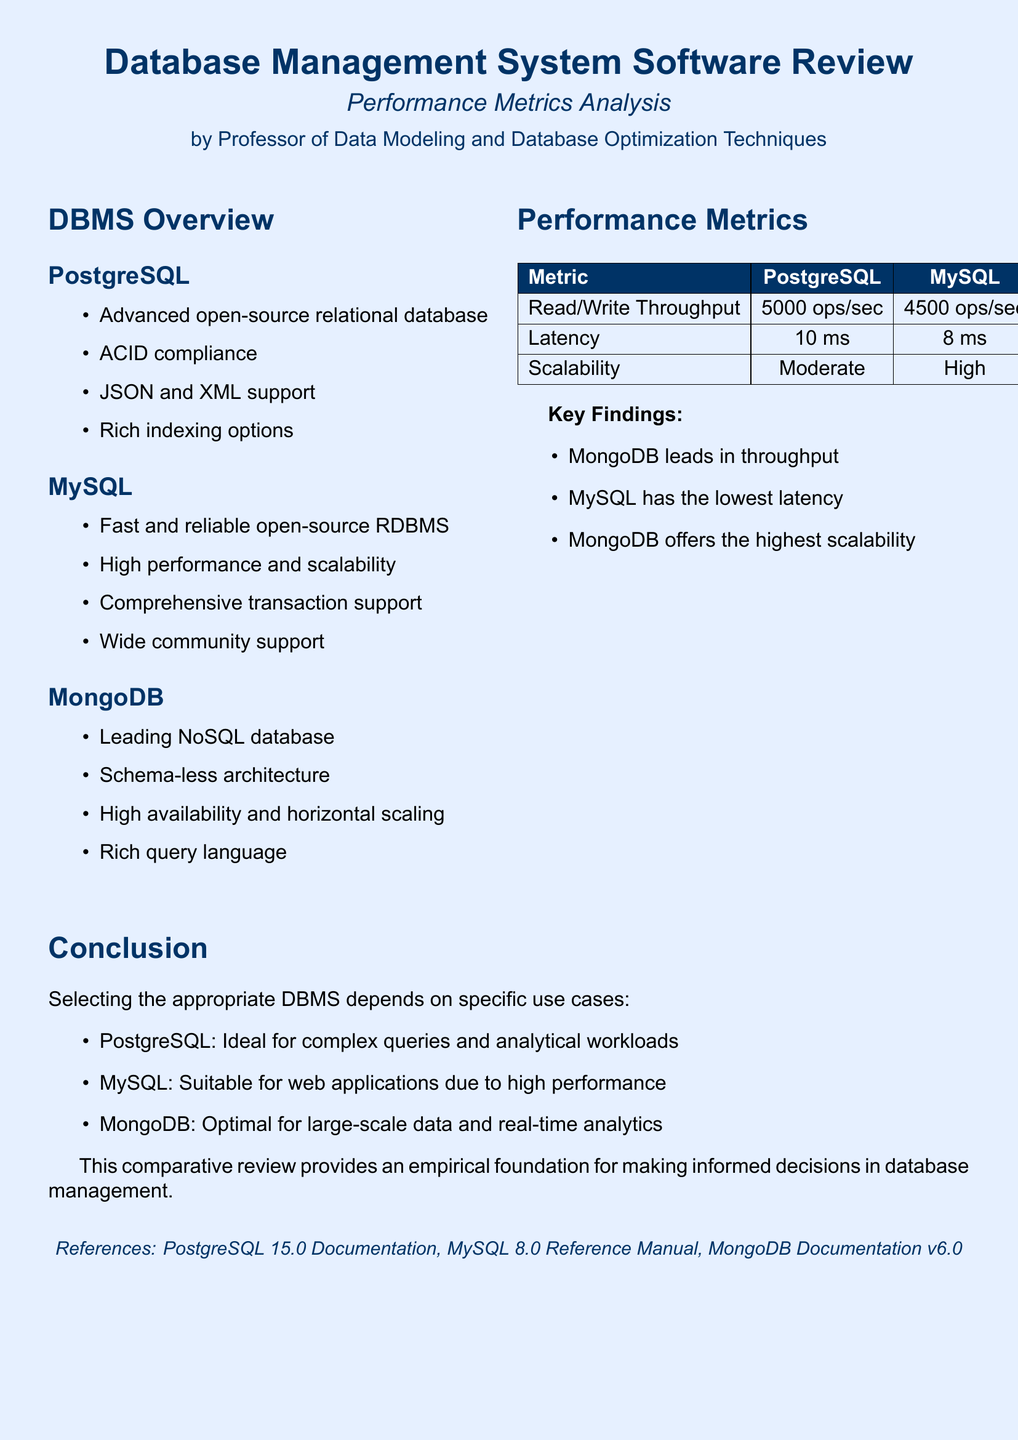What is the throughput for PostgreSQL? The throughput for PostgreSQL is listed under the Read/Write Throughput metric in the document.
Answer: 5000 ops/sec What is the latency figure for MySQL? The latency figure for MySQL can be found in the Performance Metrics table of the document.
Answer: 8 ms Which DBMS has the highest scalability? The highest scalability is indicated in the Performance Metrics section comparing the three databases.
Answer: MongoDB What type of architecture does MongoDB use? The document mentions that MongoDB has a schema-less architecture in its overview.
Answer: Schema-less What is the performance characteristic of PostgreSQL as per its conclusion? The conclusion section describes PostgreSQL’s suitability for complex queries and analytical workloads.
Answer: Ideal for complex queries Which database offers the lowest latency? The Performance Metrics table allows for comparison of latency across the databases.
Answer: MySQL What documentation references are provided? The references are listed at the bottom of the document, which includes various DBMS documentation.
Answer: PostgreSQL 15.0 Documentation, MySQL 8.0 Reference Manual, MongoDB Documentation v6.0 What metric does MongoDB excel in according to the key findings? The key findings summarize the performance strengths of each DBMS, particularly in throughput.
Answer: Throughput 